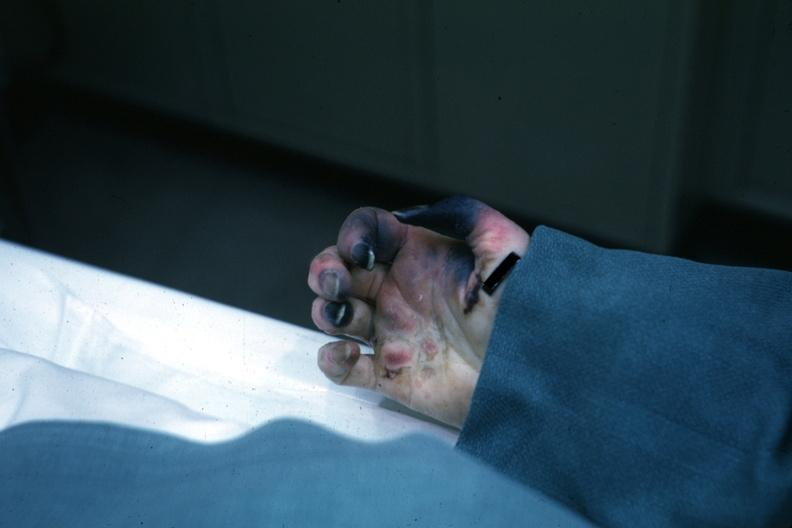s gangrene fingers present?
Answer the question using a single word or phrase. Yes 